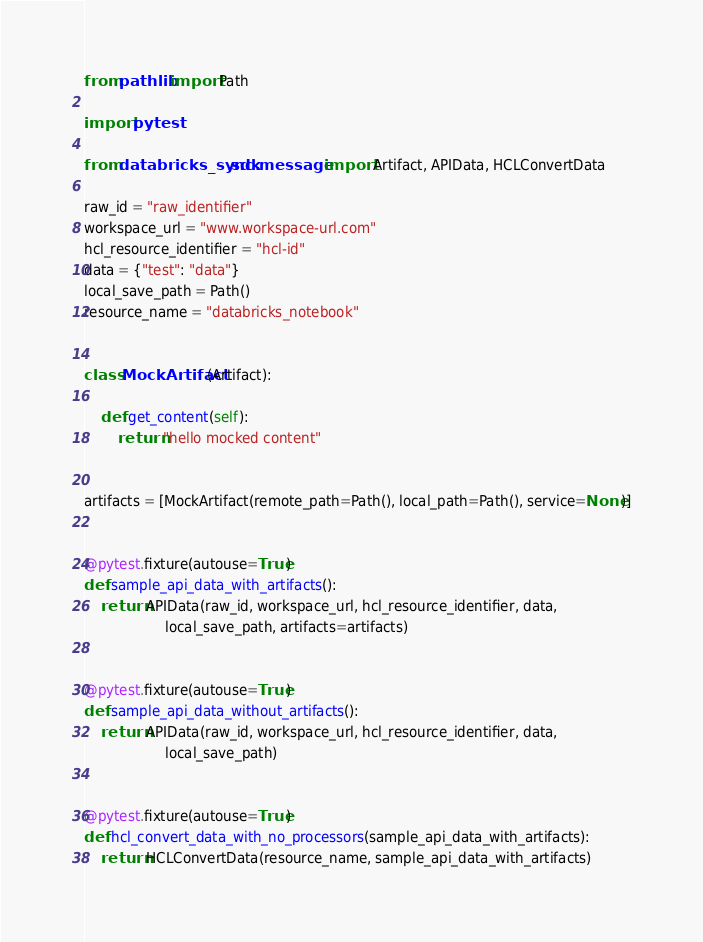Convert code to text. <code><loc_0><loc_0><loc_500><loc_500><_Python_>from pathlib import Path

import pytest

from databricks_sync.sdk.message import Artifact, APIData, HCLConvertData

raw_id = "raw_identifier"
workspace_url = "www.workspace-url.com"
hcl_resource_identifier = "hcl-id"
data = {"test": "data"}
local_save_path = Path()
resource_name = "databricks_notebook"


class MockArtifact(Artifact):

    def get_content(self):
        return "hello mocked content"


artifacts = [MockArtifact(remote_path=Path(), local_path=Path(), service=None)]


@pytest.fixture(autouse=True)
def sample_api_data_with_artifacts():
    return APIData(raw_id, workspace_url, hcl_resource_identifier, data,
                   local_save_path, artifacts=artifacts)


@pytest.fixture(autouse=True)
def sample_api_data_without_artifacts():
    return APIData(raw_id, workspace_url, hcl_resource_identifier, data,
                   local_save_path)


@pytest.fixture(autouse=True)
def hcl_convert_data_with_no_processors(sample_api_data_with_artifacts):
    return HCLConvertData(resource_name, sample_api_data_with_artifacts)
</code> 